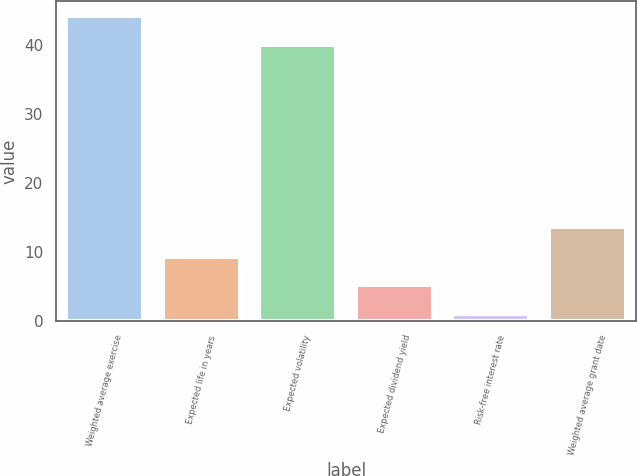<chart> <loc_0><loc_0><loc_500><loc_500><bar_chart><fcel>Weighted average exercise<fcel>Expected life in years<fcel>Expected volatility<fcel>Expected dividend yield<fcel>Risk-free interest rate<fcel>Weighted average grant date<nl><fcel>44.13<fcel>9.26<fcel>40<fcel>5.13<fcel>1<fcel>13.57<nl></chart> 